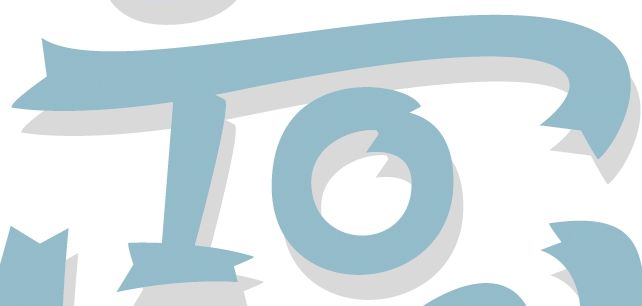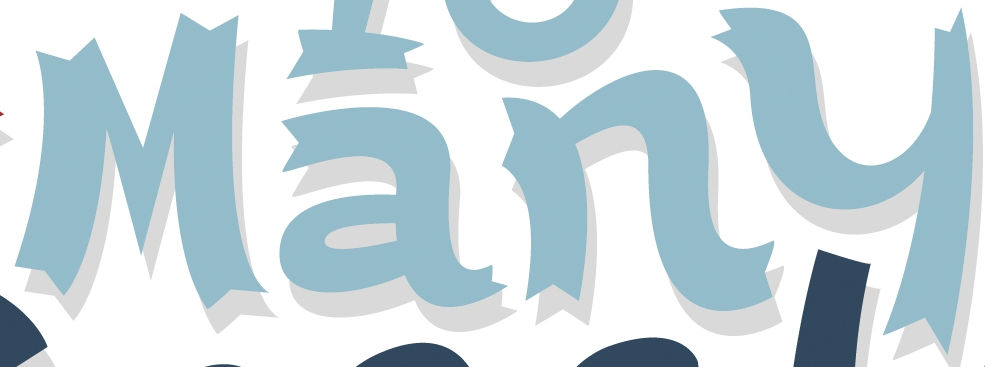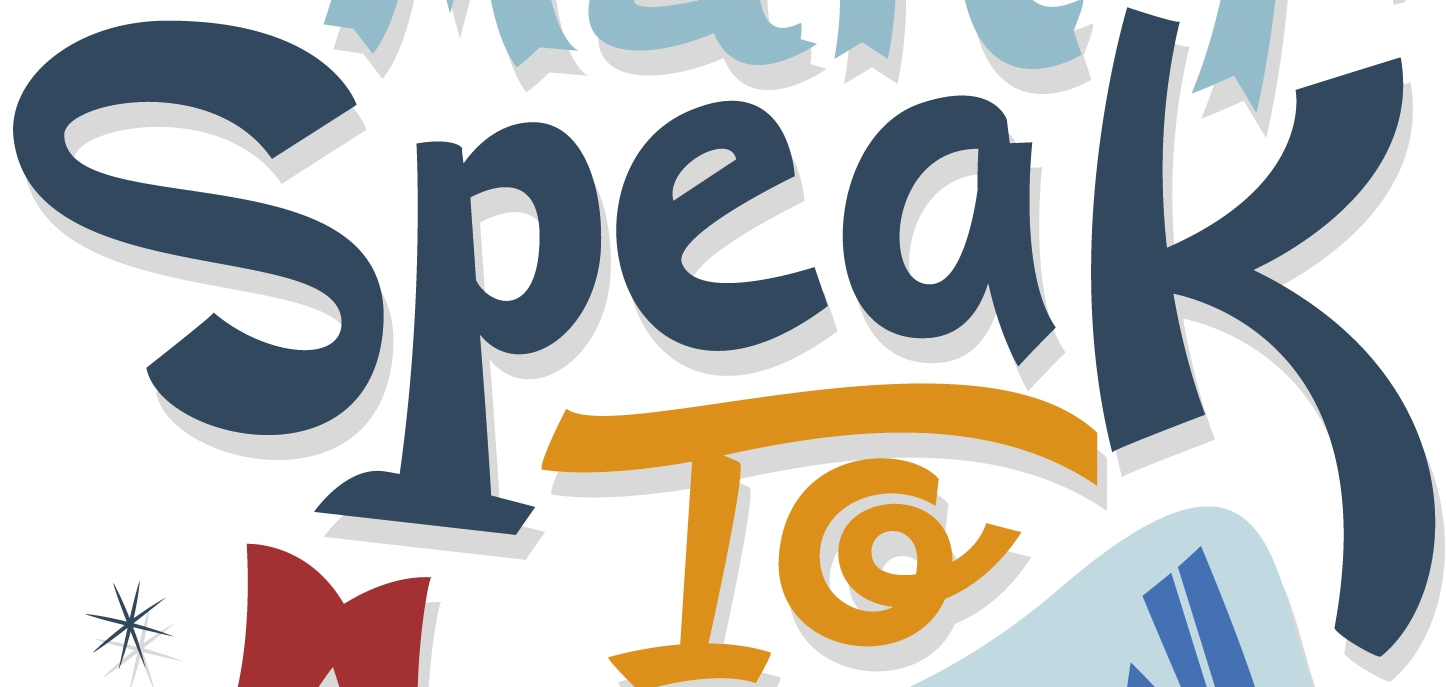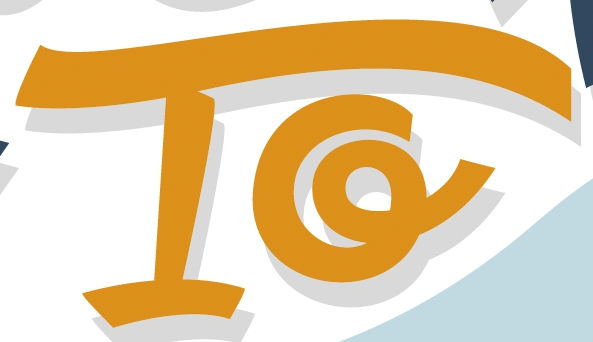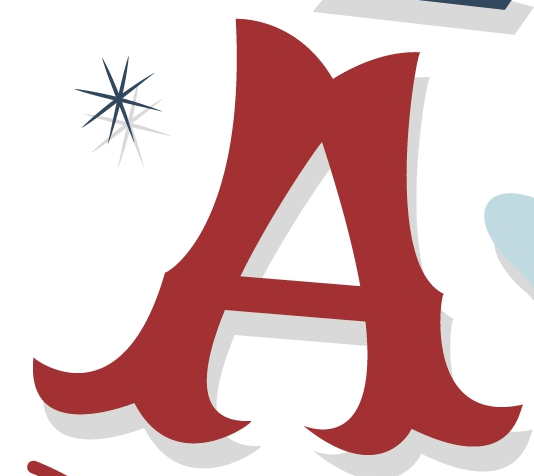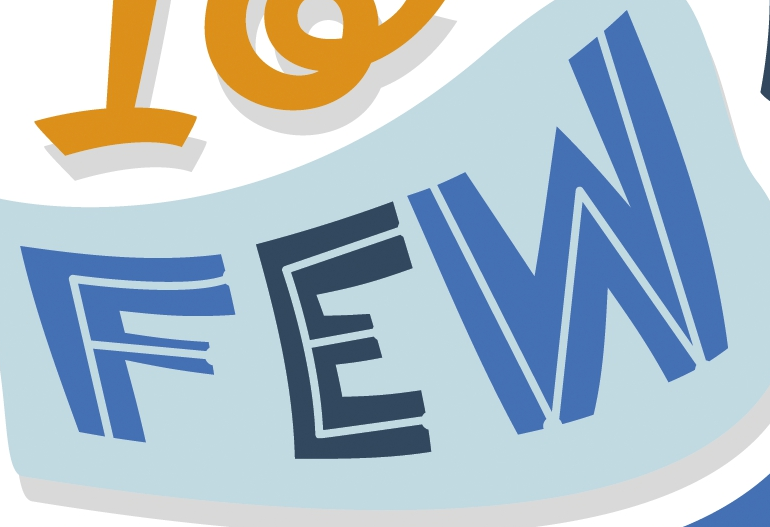What text appears in these images from left to right, separated by a semicolon? To; Many; Speak; To; A; FEW 